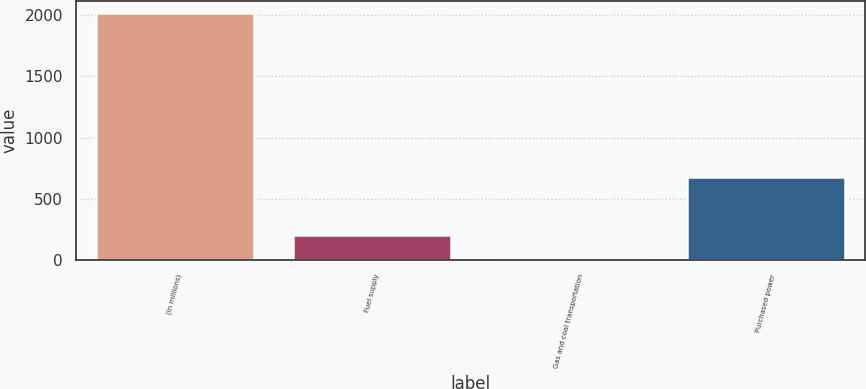Convert chart. <chart><loc_0><loc_0><loc_500><loc_500><bar_chart><fcel>(in millions)<fcel>Fuel supply<fcel>Gas and coal transportation<fcel>Purchased power<nl><fcel>2014<fcel>208.6<fcel>8<fcel>682<nl></chart> 